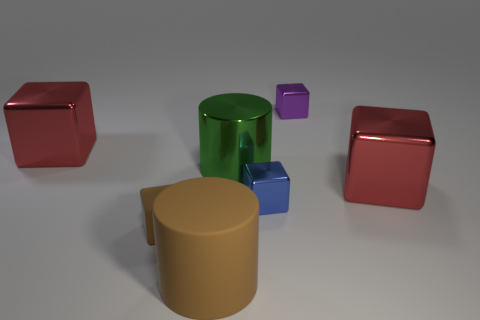Subtract all purple blocks. How many blocks are left? 4 Subtract all blue metal blocks. How many blocks are left? 4 Add 1 brown cylinders. How many objects exist? 8 Subtract all yellow cubes. Subtract all red cylinders. How many cubes are left? 5 Subtract all cubes. How many objects are left? 2 Subtract 0 blue balls. How many objects are left? 7 Subtract all tiny cyan metal cylinders. Subtract all blue things. How many objects are left? 6 Add 3 tiny blue metal blocks. How many tiny blue metal blocks are left? 4 Add 7 big yellow shiny spheres. How many big yellow shiny spheres exist? 7 